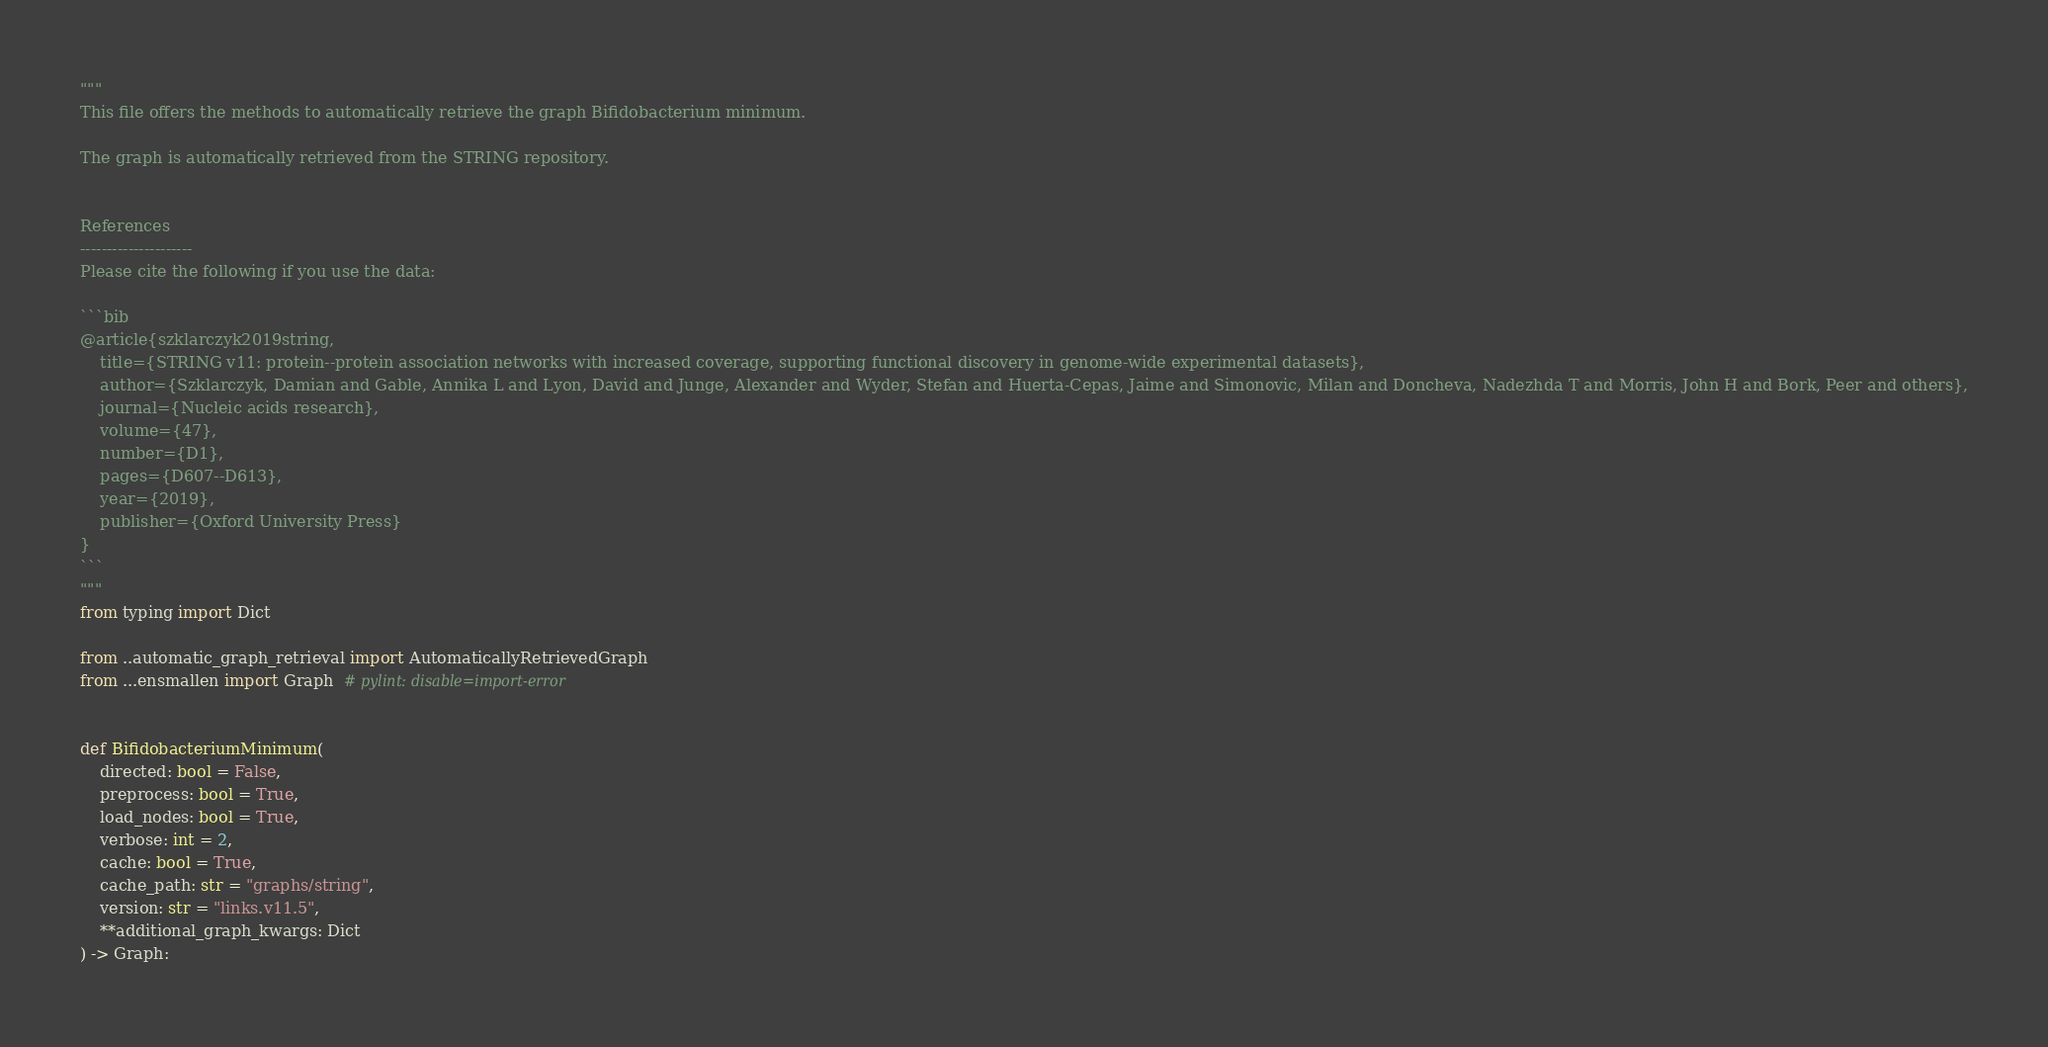Convert code to text. <code><loc_0><loc_0><loc_500><loc_500><_Python_>"""
This file offers the methods to automatically retrieve the graph Bifidobacterium minimum.

The graph is automatically retrieved from the STRING repository. 


References
---------------------
Please cite the following if you use the data:

```bib
@article{szklarczyk2019string,
    title={STRING v11: protein--protein association networks with increased coverage, supporting functional discovery in genome-wide experimental datasets},
    author={Szklarczyk, Damian and Gable, Annika L and Lyon, David and Junge, Alexander and Wyder, Stefan and Huerta-Cepas, Jaime and Simonovic, Milan and Doncheva, Nadezhda T and Morris, John H and Bork, Peer and others},
    journal={Nucleic acids research},
    volume={47},
    number={D1},
    pages={D607--D613},
    year={2019},
    publisher={Oxford University Press}
}
```
"""
from typing import Dict

from ..automatic_graph_retrieval import AutomaticallyRetrievedGraph
from ...ensmallen import Graph  # pylint: disable=import-error


def BifidobacteriumMinimum(
    directed: bool = False,
    preprocess: bool = True,
    load_nodes: bool = True,
    verbose: int = 2,
    cache: bool = True,
    cache_path: str = "graphs/string",
    version: str = "links.v11.5",
    **additional_graph_kwargs: Dict
) -> Graph:</code> 